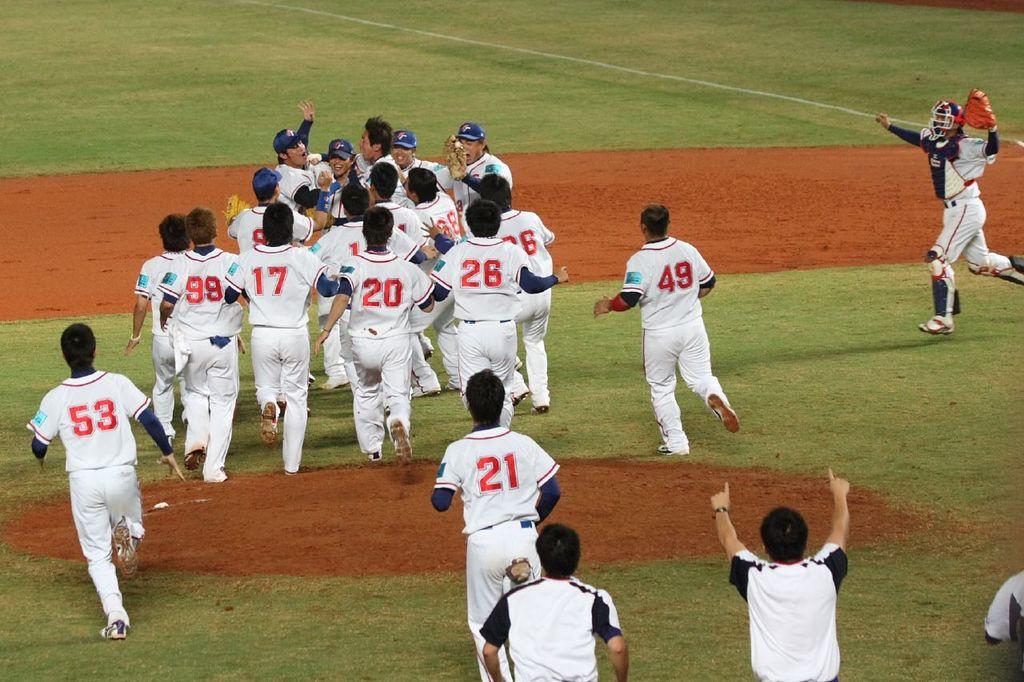What is the number of the player furthest to the left?
Provide a succinct answer. 53. What kind of players are on the field?
Offer a very short reply. Answering does not require reading text in the image. 